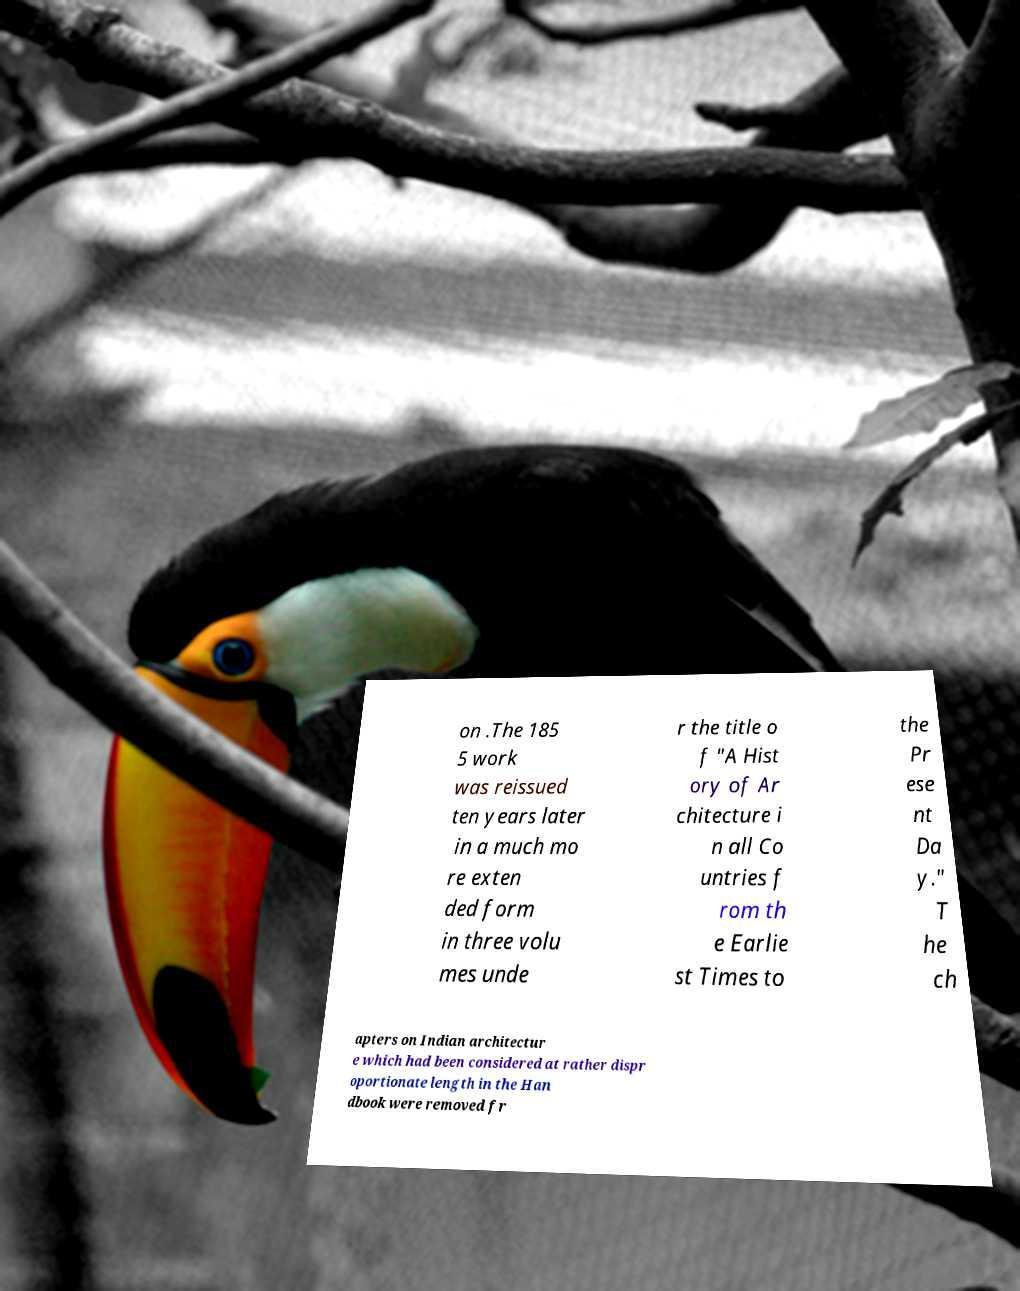There's text embedded in this image that I need extracted. Can you transcribe it verbatim? on .The 185 5 work was reissued ten years later in a much mo re exten ded form in three volu mes unde r the title o f "A Hist ory of Ar chitecture i n all Co untries f rom th e Earlie st Times to the Pr ese nt Da y." T he ch apters on Indian architectur e which had been considered at rather dispr oportionate length in the Han dbook were removed fr 